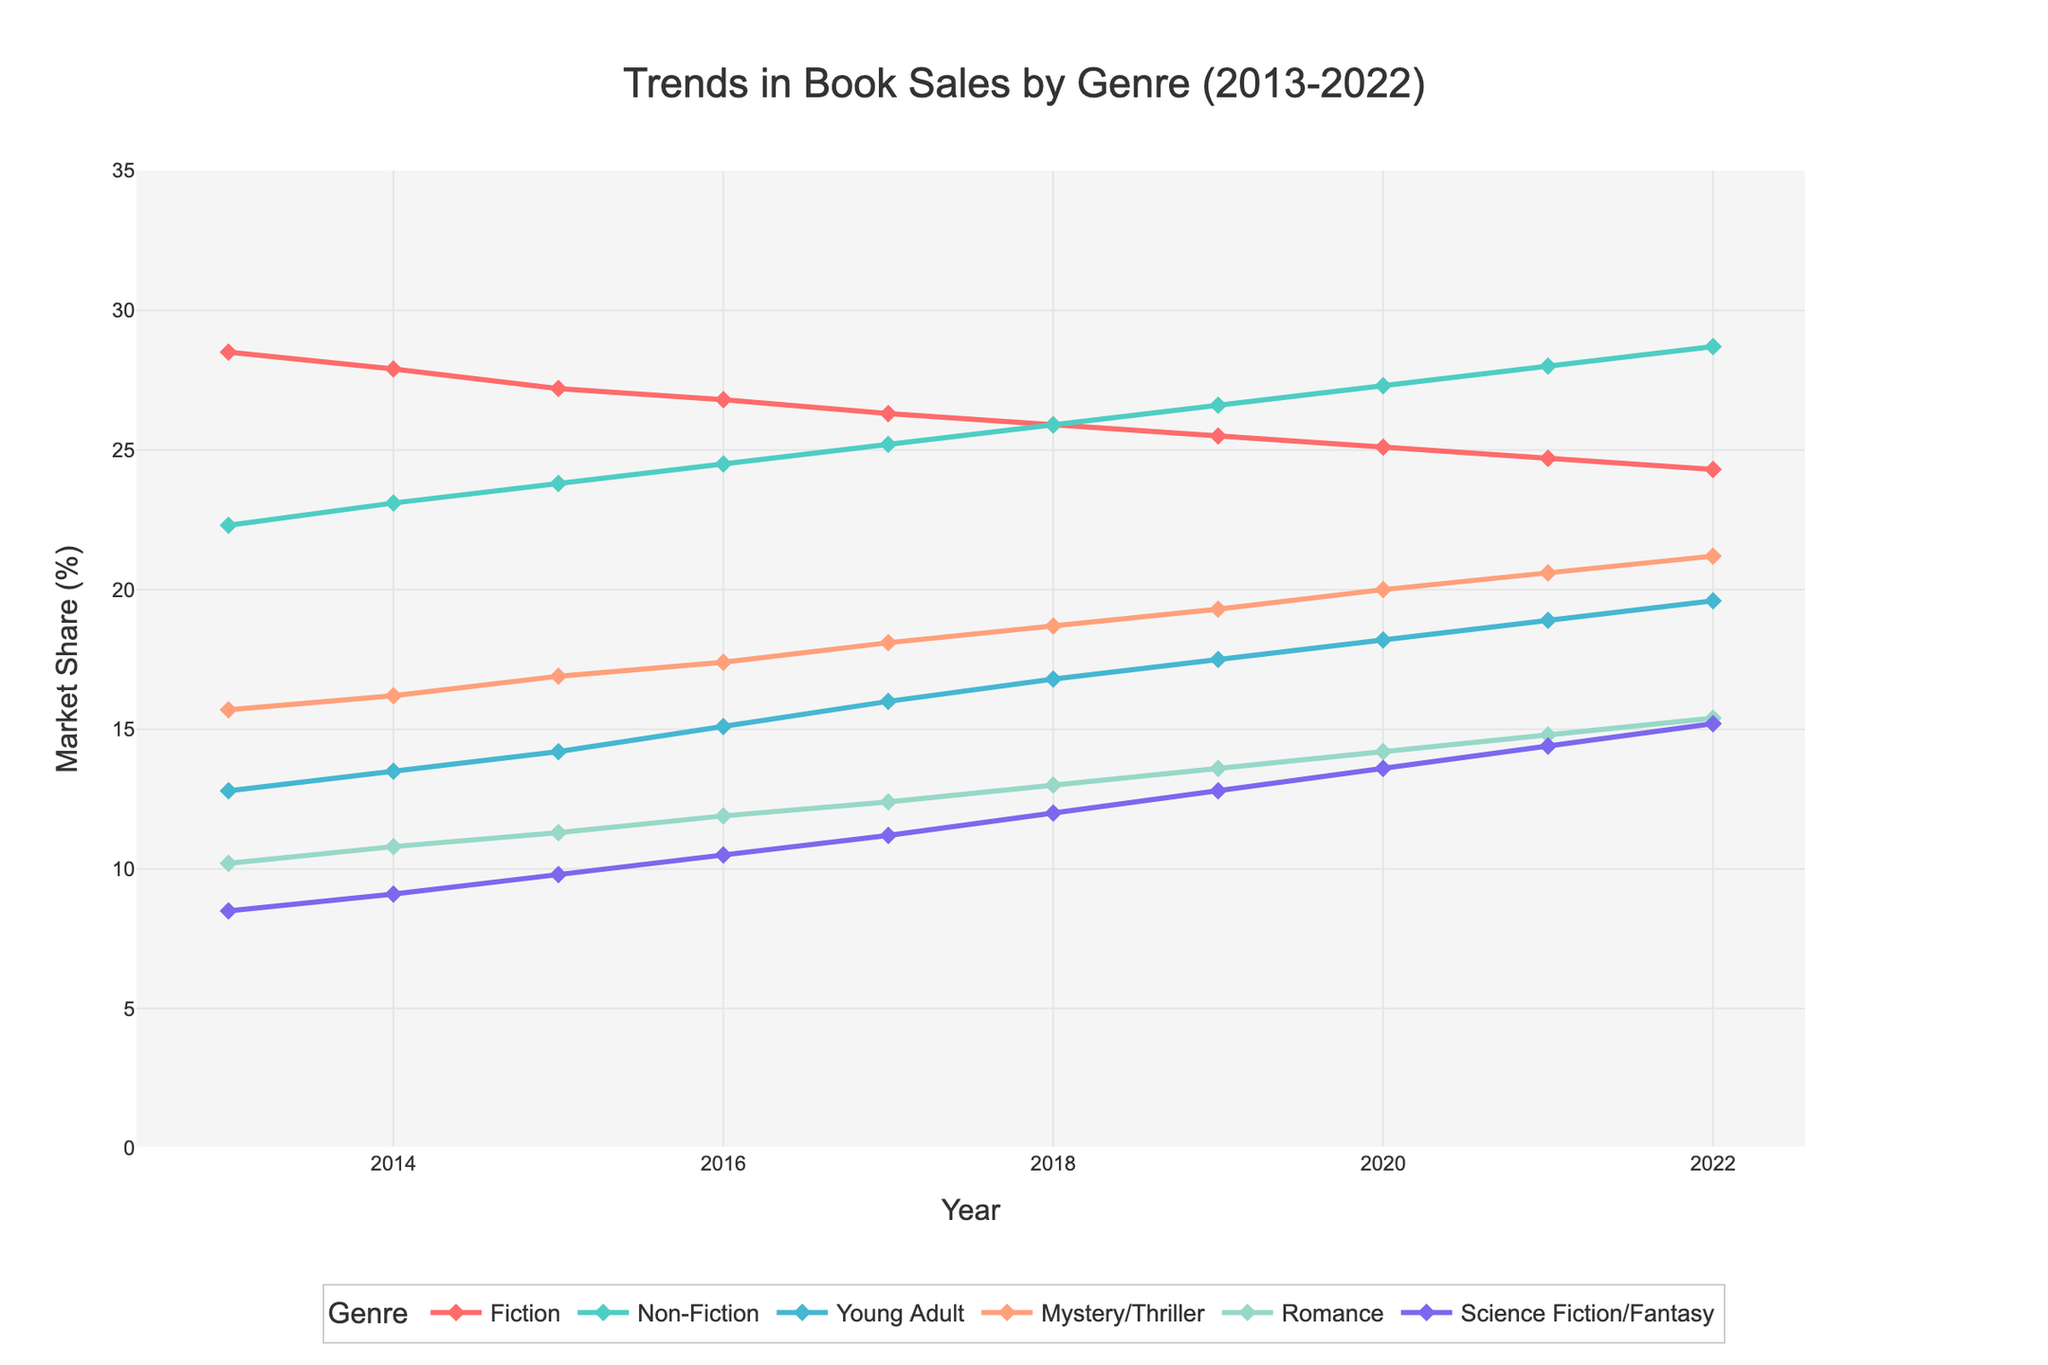What's the most popular genre in 2022? The line representing Non-Fiction has the highest point in 2022.
Answer: Non-Fiction Which genre saw the most significant rise in sales from 2013 to 2022? Compare the slope of the lines from 2013 to 2022. Science Fiction/Fantasy shows the greatest increase, rising from 8.5 to 15.2.
Answer: Science Fiction/Fantasy By how much did Young Adult sales increase from 2013 to 2022? Subtract the 2013 value from the 2022 value for Young Adult. 19.6 - 12.8 = 6.8.
Answer: 6.8 How do the slopes of Fiction and Non-Fiction compare between 2013 and 2022? Calculate the slope for each genre. Fiction decreases from 28.5 to 24.3, whereas Non-Fiction increases from 22.3 to 28.7. The slope for Fiction is negative, and for Non-Fiction, it's positive.
Answer: Fiction decreases; Non-Fiction increases In which year did Mystery/Thriller surpass Fiction in sales? Identify the intersection point of the lines for Mystery/Thriller and Fiction. This occurs between 2018 and 2019.
Answer: 2019 On average, which genre showed the least variance in market share over the decade? Observe the spread of each genre's line. Fiction's line appears the least variable, bouncing between 28.5 and 24.3.
Answer: Fiction What is the total market share of Romance and Science Fiction/Fantasy in 2013? Add the values for Romance and Science Fiction/Fantasy in 2013. 10.2 + 8.5 = 18.7.
Answer: 18.7 Between which two consecutive years did Young Adult see the most significant increase? Identify the year span with the steepest slope for Young Adult. The largest increase occurs between 2016 and 2017, from 15.1 to 16.0.
Answer: 2016-2017 Which genre had the smallest market share in 2022, and what was it? Look at the endpoint of each line in 2022. Young Adult shows the least climb, with a value of 19.6.
Answer: Young Adult, 19.6 How did the sales trends of Non-Fiction and Romance compare from 2013 to 2022? Compare both lines. Non-Fiction displays a steady rise from 22.3 to 28.7, while Romance slowly increases from 10.2 to 15.4. Non-Fiction's rise is more substantial.
Answer: Non-Fiction's increase is more substantial than Romance's 